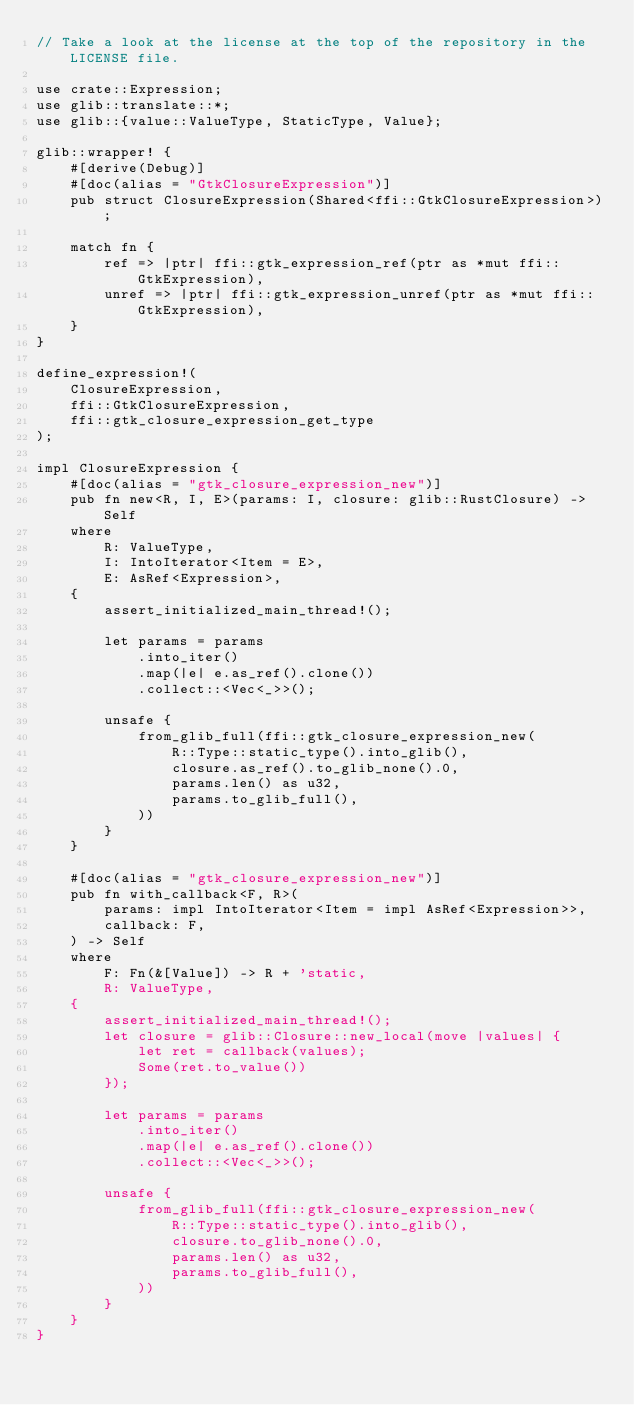<code> <loc_0><loc_0><loc_500><loc_500><_Rust_>// Take a look at the license at the top of the repository in the LICENSE file.

use crate::Expression;
use glib::translate::*;
use glib::{value::ValueType, StaticType, Value};

glib::wrapper! {
    #[derive(Debug)]
    #[doc(alias = "GtkClosureExpression")]
    pub struct ClosureExpression(Shared<ffi::GtkClosureExpression>);

    match fn {
        ref => |ptr| ffi::gtk_expression_ref(ptr as *mut ffi::GtkExpression),
        unref => |ptr| ffi::gtk_expression_unref(ptr as *mut ffi::GtkExpression),
    }
}

define_expression!(
    ClosureExpression,
    ffi::GtkClosureExpression,
    ffi::gtk_closure_expression_get_type
);

impl ClosureExpression {
    #[doc(alias = "gtk_closure_expression_new")]
    pub fn new<R, I, E>(params: I, closure: glib::RustClosure) -> Self
    where
        R: ValueType,
        I: IntoIterator<Item = E>,
        E: AsRef<Expression>,
    {
        assert_initialized_main_thread!();

        let params = params
            .into_iter()
            .map(|e| e.as_ref().clone())
            .collect::<Vec<_>>();

        unsafe {
            from_glib_full(ffi::gtk_closure_expression_new(
                R::Type::static_type().into_glib(),
                closure.as_ref().to_glib_none().0,
                params.len() as u32,
                params.to_glib_full(),
            ))
        }
    }

    #[doc(alias = "gtk_closure_expression_new")]
    pub fn with_callback<F, R>(
        params: impl IntoIterator<Item = impl AsRef<Expression>>,
        callback: F,
    ) -> Self
    where
        F: Fn(&[Value]) -> R + 'static,
        R: ValueType,
    {
        assert_initialized_main_thread!();
        let closure = glib::Closure::new_local(move |values| {
            let ret = callback(values);
            Some(ret.to_value())
        });

        let params = params
            .into_iter()
            .map(|e| e.as_ref().clone())
            .collect::<Vec<_>>();

        unsafe {
            from_glib_full(ffi::gtk_closure_expression_new(
                R::Type::static_type().into_glib(),
                closure.to_glib_none().0,
                params.len() as u32,
                params.to_glib_full(),
            ))
        }
    }
}
</code> 